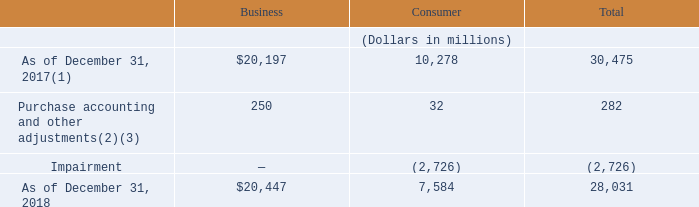We completed our qualitative assessment of our indefinite-lived intangible assets other than goodwill as of December 31, 2019 and 2018 and concluded it is more likely than not that our indefinite-lived intangible assets are not impaired; thus, no impairment charge for these assets was recorded in 2019 or 2018.
The following tables show the rollforward of goodwill assigned to our reportable segments from December 31, 2017 through December 31, 2019.
(1) Goodwill is net of accumulated impairment losses of $1.1 billion that related to our former hosting segment now included in our business segment.
(2) We allocated $32 million of Level 3 goodwill to consumer as we expect the consumer segment to benefit from synergies resulting from the business combination. (2) We allocated $32 million of Level 3 goodwill to consumer as we expect the consumer segment to benefit from synergies resulting from the business combination.
(3) Includes $58 million decrease due to effect of foreign currency exchange rate change.
What is goodwill assigned to business as of December 31, 2017?
Answer scale should be: million. $20,197. How much of Level 3 goodwill is allocated to consumer? $32 million. Which are the reportable segments highlighted in the table? Business, consumer. What is the amount of goodwill under Business as a ratio of the Total amount as of December 31, 2018?
Answer scale should be: percent. 20,447/28,031
Answer: 0.73. What is the sum of the total amount of goodwill for 2017 and 2018?
Answer scale should be: million. 30,475+28,031
Answer: 58506. What is the average total amount of goodwill for 2017 and 2018?
Answer scale should be: million. (30,475+28,031)/2
Answer: 29253. 